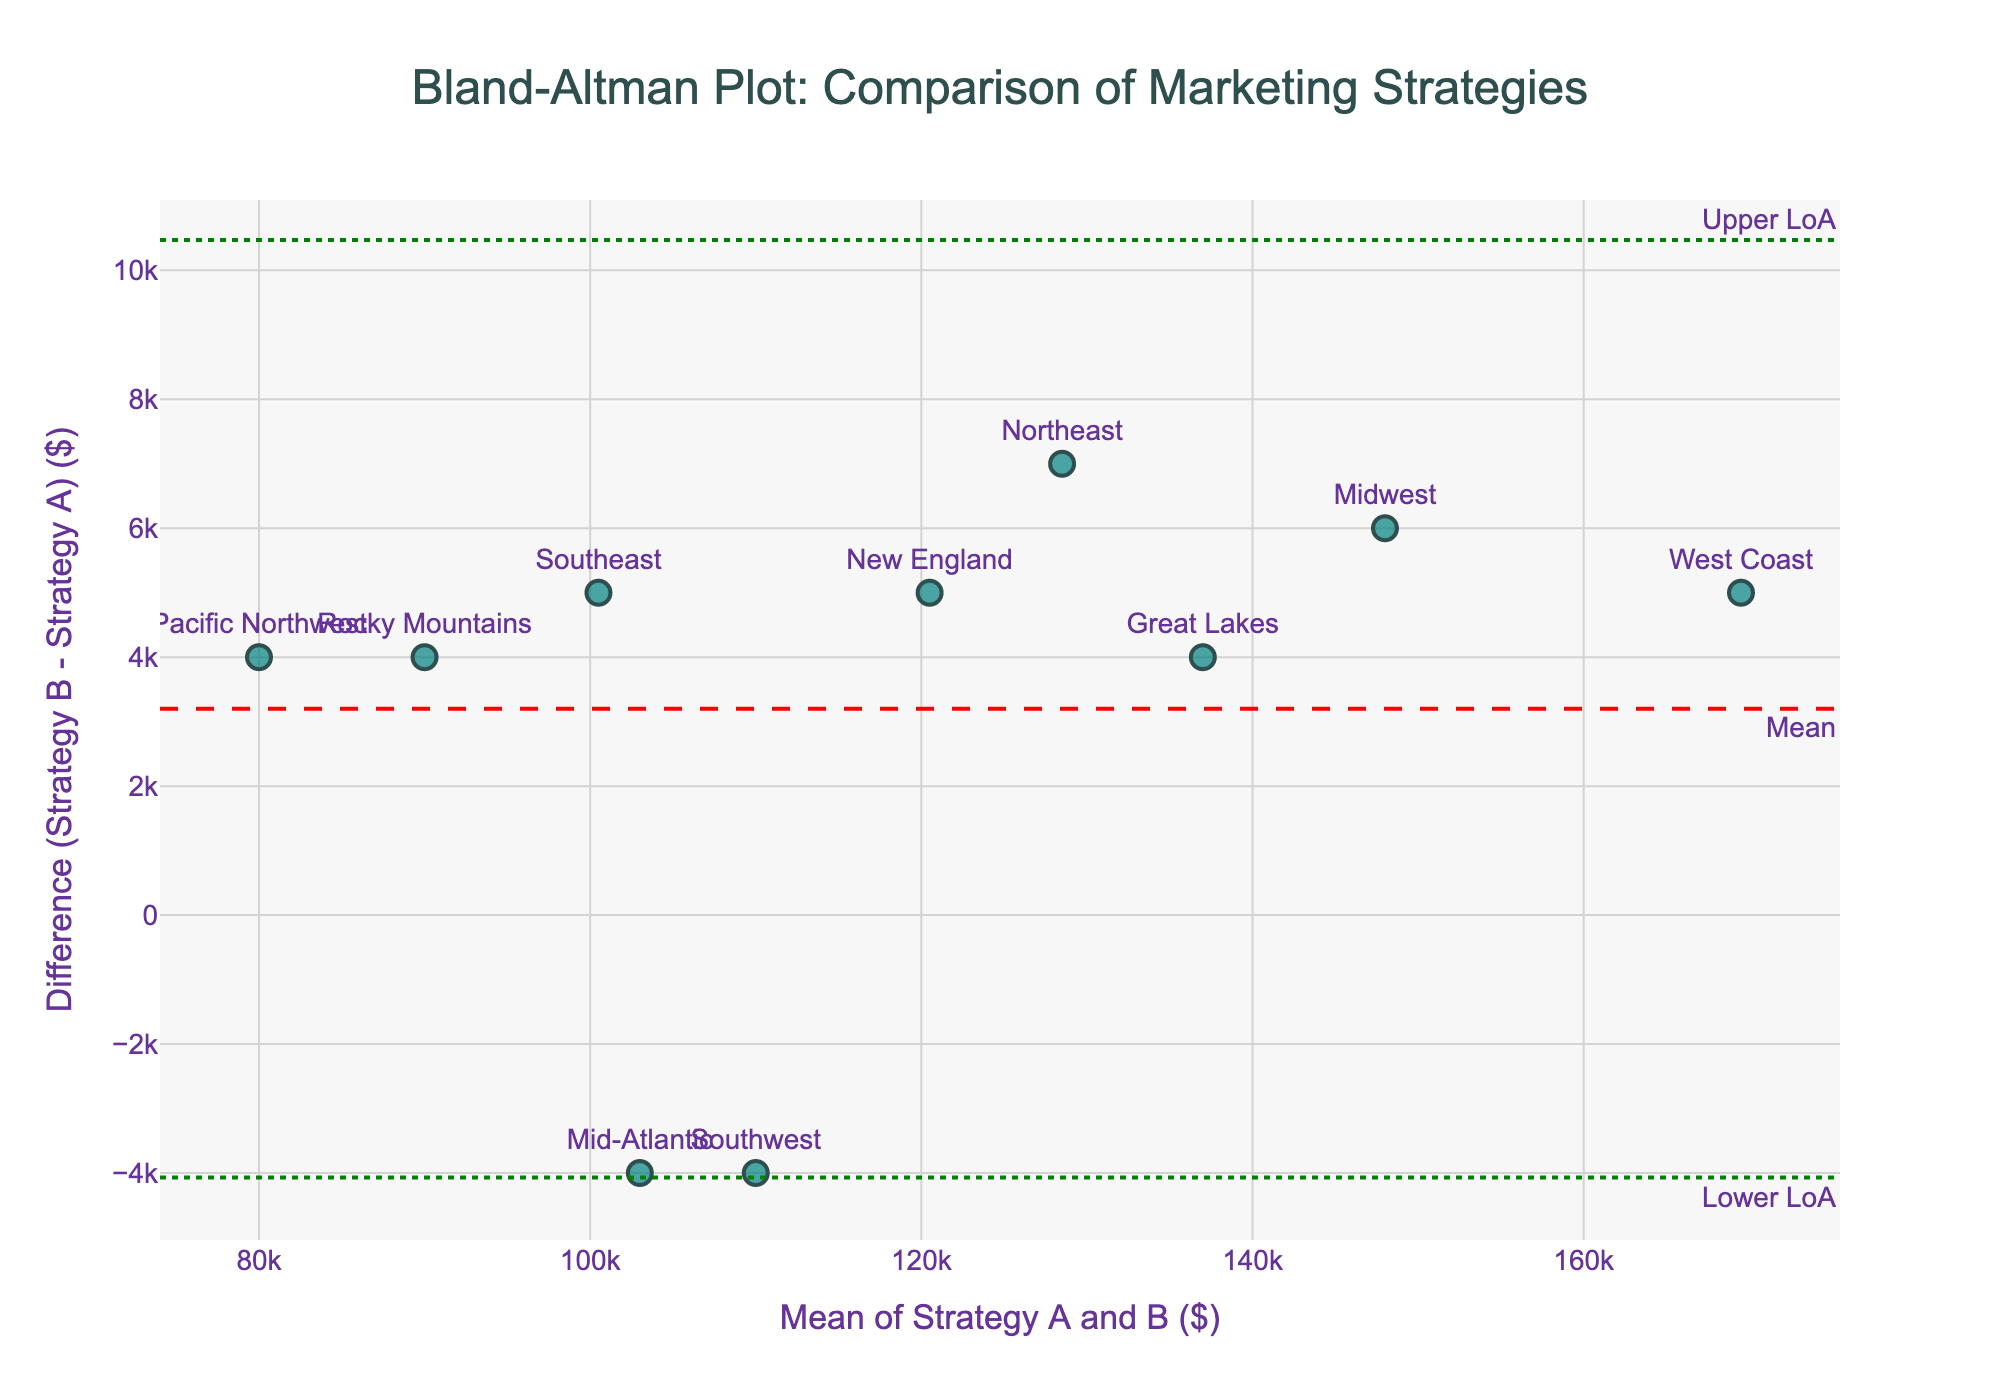What's the title of the plot? The title is located at the top of the plot. It reads, "Bland-Altman Plot: Comparison of Marketing Strategies".
Answer: Bland-Altman Plot: Comparison of Marketing Strategies What is the x-axis representing? The x-axis label is found below the axis and indicates that it represents "Mean of Strategy A and B ($)".
Answer: Mean of Strategy A and B ($) How many data points are shown in the plot? By counting the number of data points (markers) on the plot, which represent different regions, we can determine their total number. There are 10 regions listed in the data, so there should be 10 data points.
Answer: 10 What is the difference between Strategy A and Strategy B for the Midwest? Locate the Midwest data point on the plot, where the "Midwest" label is positioned. The y-axis value for this point represents the difference (Strategy B - Strategy A). For the Midwest, the difference can be calculated directly from the data: 151,000 - 145,000 = 6,000.
Answer: 6,000 Which region has the highest mean value of Strategy A and Strategy B? To find the highest mean value, locate the highest x-axis value since the x-axis represents the mean of Strategies A and B. The West Coast data point is the farthest to the right, indicating it has the highest mean.
Answer: West Coast What are the upper and lower limits of agreement in the plot? The upper and lower limits of agreement are visually represented as horizontal dotted green lines. Their values are also annotated next to these lines as "Upper LoA" and "Lower LoA."
Answer: Upper limit: ~7,960, Lower limit: ~-12,360 Which region has the greatest positive difference between Strategy A and Strategy B? The greatest positive difference is represented by the highest point on the y-axis, where the difference is most positive. The West Coast data point appears highest on the y-axis.
Answer: West Coast What is the mean difference across all regions? The mean difference is visually represented by the horizontal dashed red line labeled "Mean." The plot shows the mean difference at approximately -2,200.
Answer: ~-2,200 Which regions fall outside the limits of agreement? Regions falling outside the limits of agreement are those whose data points are above the upper limit (Upper LoA) or below the lower limit (Lower LoA). Looking at the plot, the Southwest and New England regions fall outside these limits.
Answer: Southwest, New England Are there more regions with positive or negative differences? Compare the number of data points above the horizontal dashed line (positive differences) with those below it (negative differences). There are more data points below the horizontal dashed line indicating negative differences.
Answer: Negative differences 